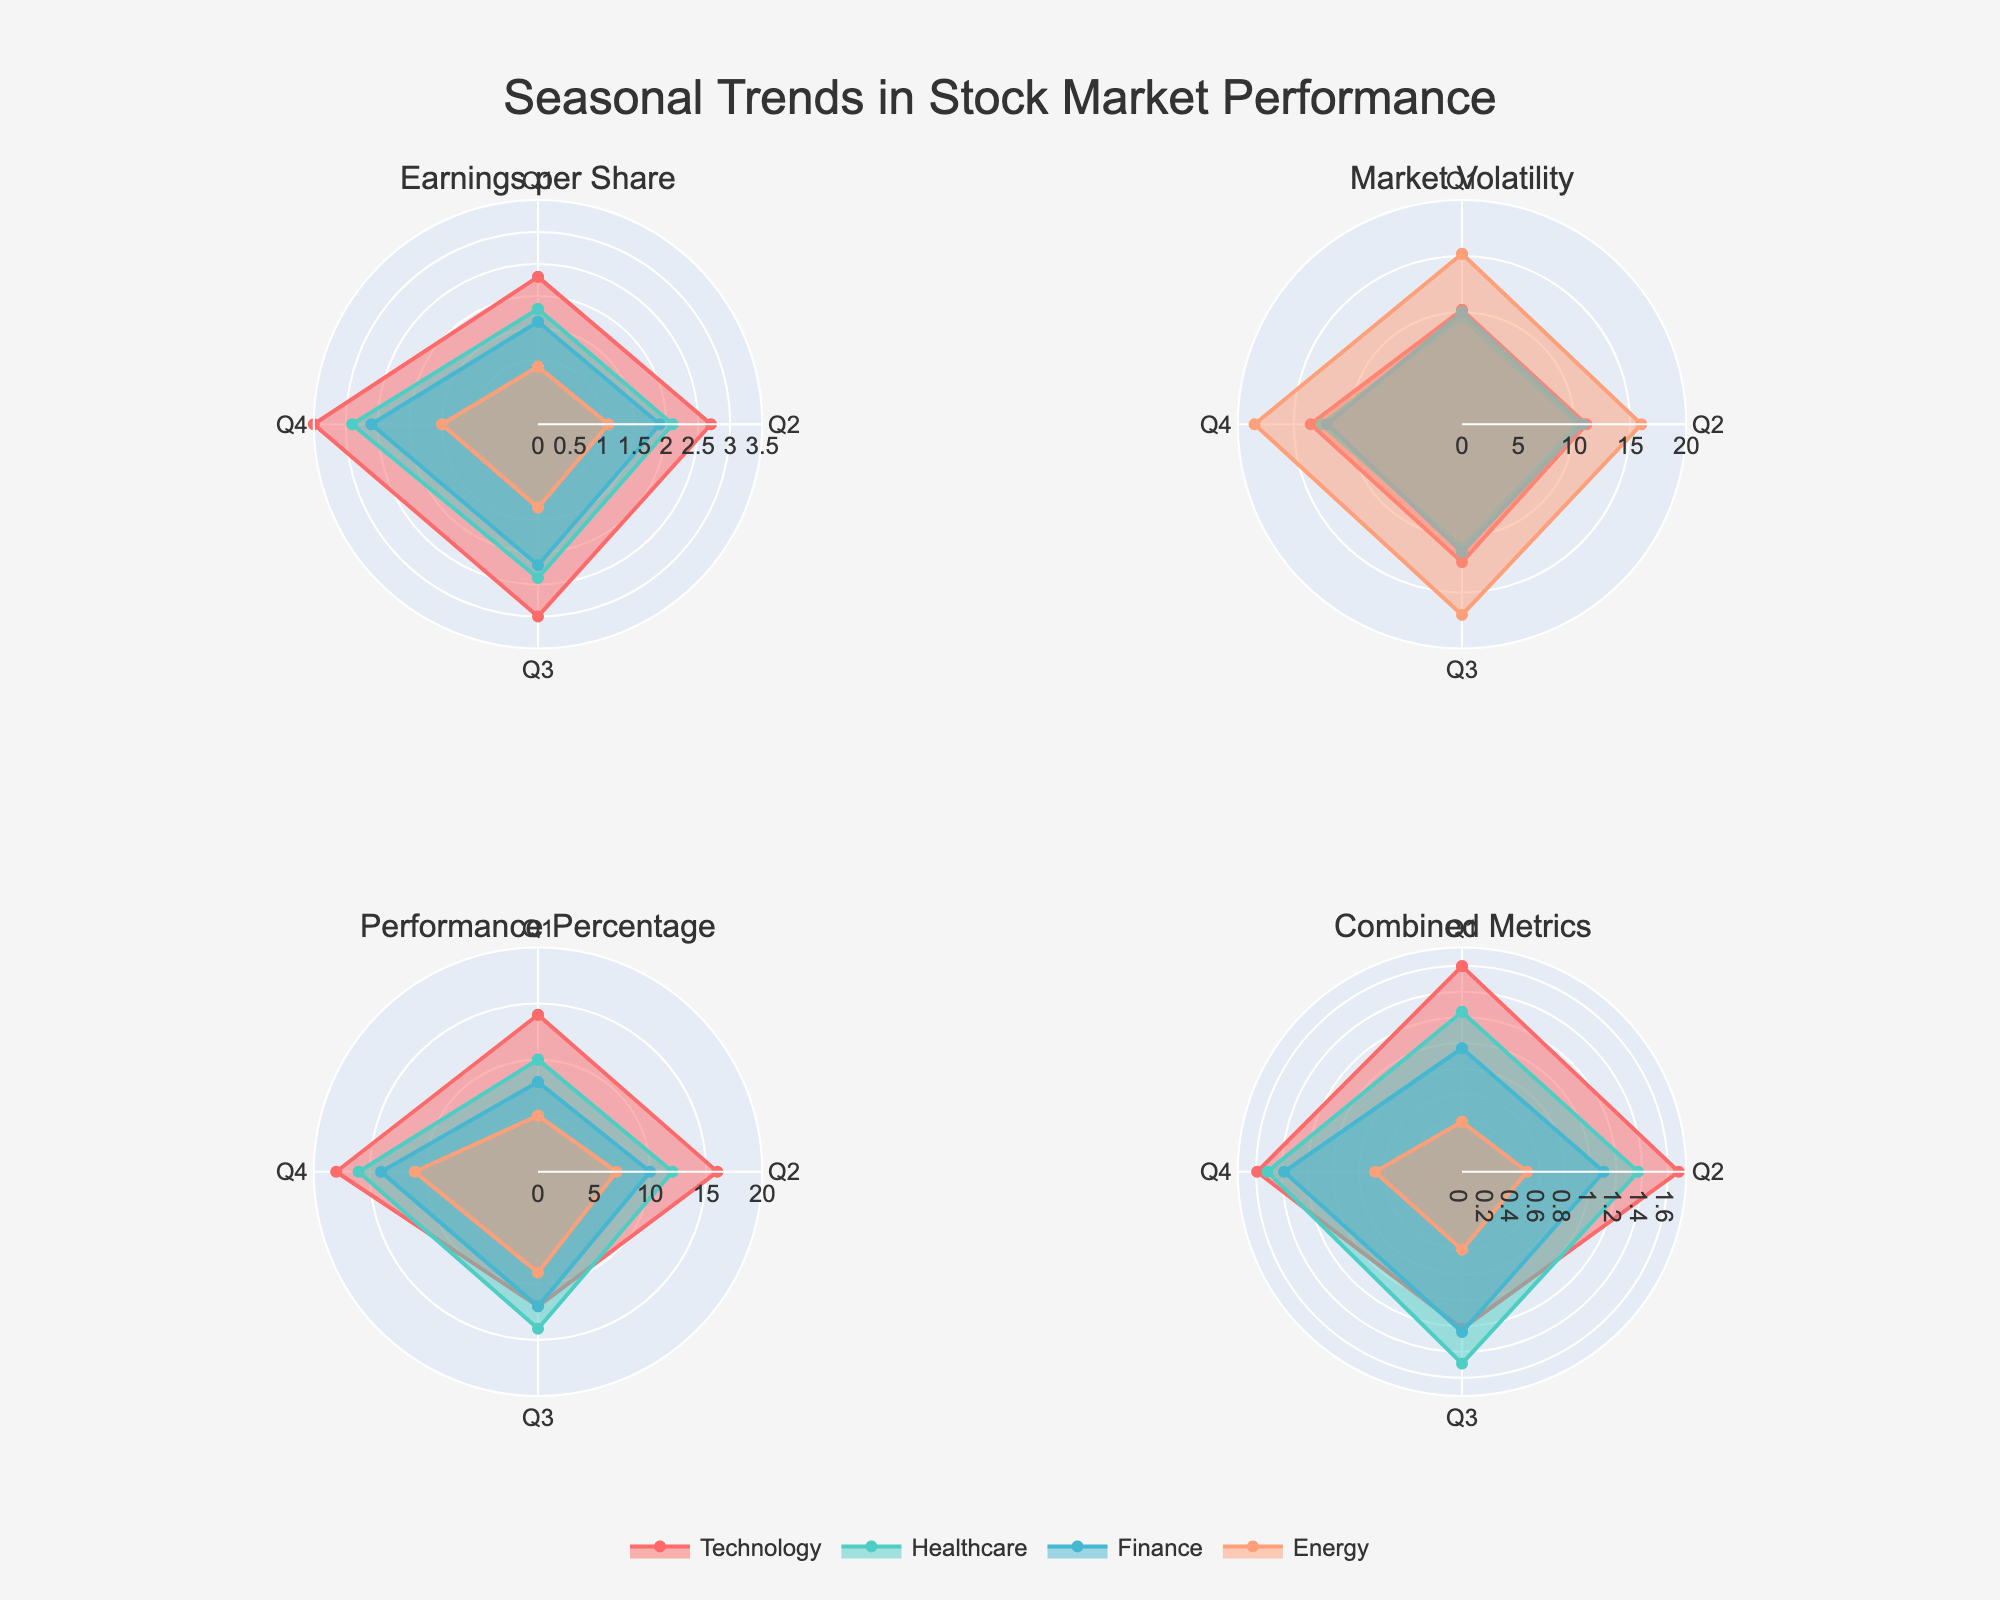What are the sectors displayed in the polar charts? The sectors displayed are those with different colors and names shown in the legend of the figure. These sectors are "Technology," "Healthcare," "Finance," and "Energy."
Answer: Technology, Healthcare, Finance, Energy Which sector has the highest earnings per share in Q4? To find the sector with the highest earnings per share in Q4, look at the subplot titled "Earnings per Share" and identify the longest radial distance for Q4. The "Technology" sector has the highest value.
Answer: Technology How does market volatility in the Energy sector compare between Q1 and Q4? Look at the "Market Volatility" subplot and compare the radial distances for the Energy sector between Q1 and Q4. The volatility increases from around 15.2% in Q1 to approximately 18.5% in Q4.
Answer: Increases Which sector shows the highest performance percentage in Q2? Refer to the "Performance Percentage" subplot and identify which sector has the longest radial distance for Q2. The "Technology" sector shows the highest performance percentage.
Answer: Technology What is the combined metric value for the Healthcare sector in Q3? In the "Combined Metrics" subplot, locate the Healthcare sector for Q3. The combined metric is calculated as (Earnings per Share + Performance Percentage) / Market Volatility. For Q3 in Healthcare, this is (2.4 + 14) / 11.0.
Answer: 1.49 In which quarter does Finance have the lowest earnings per share? Look at the "Earnings per Share" subplot and compare the radial distances for Finance across all quarters. The lowest earnings per share for Finance is in Q1.
Answer: Q1 By how much does the performance percentage increase for Technology from Q3 to Q4? To determine the increase, look at the "Performance Percentage" subplot and note the radial distances for Technology in Q3 and Q4. The performance percentage increases from 12% to 18%, resulting in an increase of 6%.
Answer: 6% Which sector has the most stable market volatility across all quarters? Check the "Market Volatility" subplot for the sector whose radial distances change the least across all quarters. The Healthcare sector shows the most stability in market volatility.
Answer: Healthcare Is the combined metric value for Technology in Q4 higher or lower compared to Q1? Calculate the combined metrics for Technology in both quarters: Q4 is (3.5 + 18) / 13.5, and Q1 is (2.3 + 14) / 10.2. By calculating, we find the Q4 value is higher.
Answer: Higher 